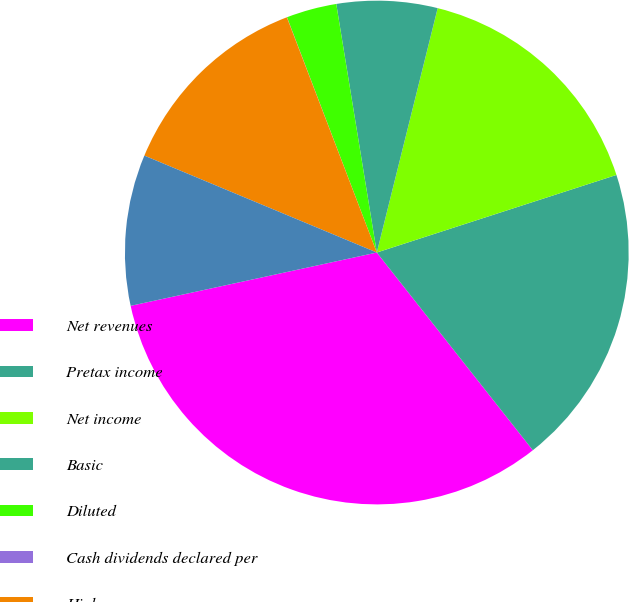Convert chart. <chart><loc_0><loc_0><loc_500><loc_500><pie_chart><fcel>Net revenues<fcel>Pretax income<fcel>Net income<fcel>Basic<fcel>Diluted<fcel>Cash dividends declared per<fcel>High<fcel>Low<nl><fcel>32.24%<fcel>19.35%<fcel>16.13%<fcel>6.46%<fcel>3.23%<fcel>0.01%<fcel>12.9%<fcel>9.68%<nl></chart> 